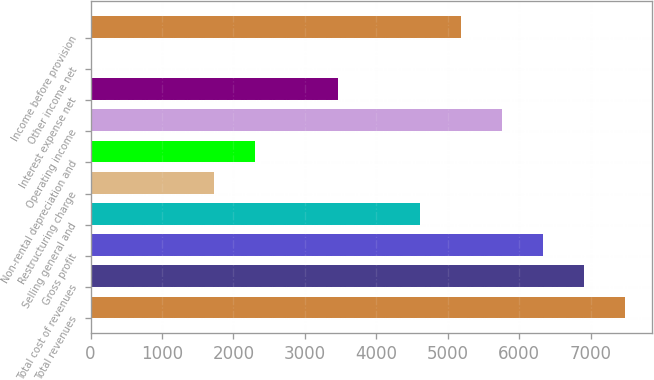Convert chart to OTSL. <chart><loc_0><loc_0><loc_500><loc_500><bar_chart><fcel>Total revenues<fcel>Total cost of revenues<fcel>Gross profit<fcel>Selling general and<fcel>Restructuring charge<fcel>Non-rental depreciation and<fcel>Operating income<fcel>Interest expense net<fcel>Other income net<fcel>Income before provision<nl><fcel>7489.1<fcel>6913.4<fcel>6337.7<fcel>4610.6<fcel>1732.1<fcel>2307.8<fcel>5762<fcel>3459.2<fcel>5<fcel>5186.3<nl></chart> 